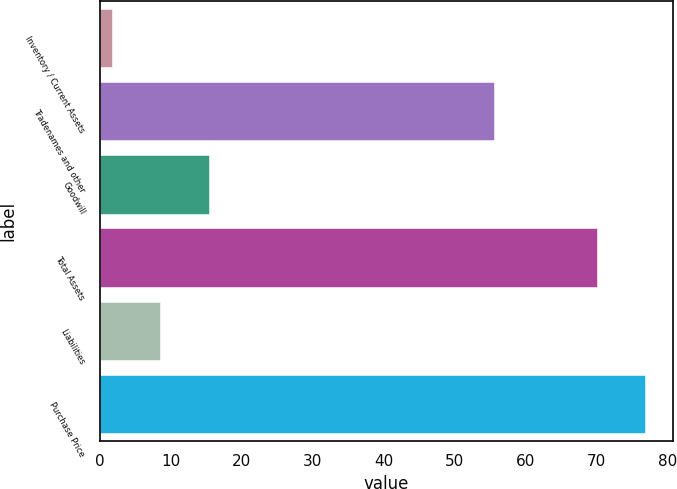Convert chart. <chart><loc_0><loc_0><loc_500><loc_500><bar_chart><fcel>Inventory / Current Assets<fcel>Tradenames and other<fcel>Goodwill<fcel>Total Assets<fcel>Liabilities<fcel>Purchase Price<nl><fcel>1.7<fcel>55.6<fcel>15.36<fcel>70<fcel>8.53<fcel>76.83<nl></chart> 